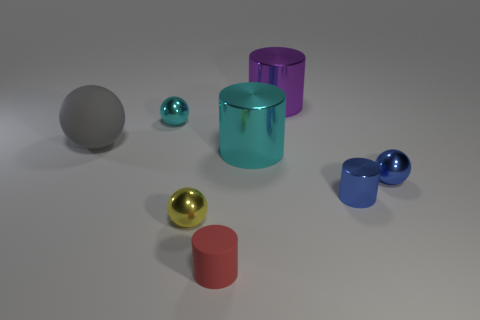Subtract all large spheres. How many spheres are left? 3 Subtract all blue cylinders. How many cylinders are left? 3 Add 1 yellow blocks. How many objects exist? 9 Subtract all large brown metal cylinders. Subtract all tiny cylinders. How many objects are left? 6 Add 6 tiny yellow balls. How many tiny yellow balls are left? 7 Add 6 small purple cubes. How many small purple cubes exist? 6 Subtract 1 blue balls. How many objects are left? 7 Subtract 1 cylinders. How many cylinders are left? 3 Subtract all brown cylinders. Subtract all purple spheres. How many cylinders are left? 4 Subtract all cyan balls. How many red cylinders are left? 1 